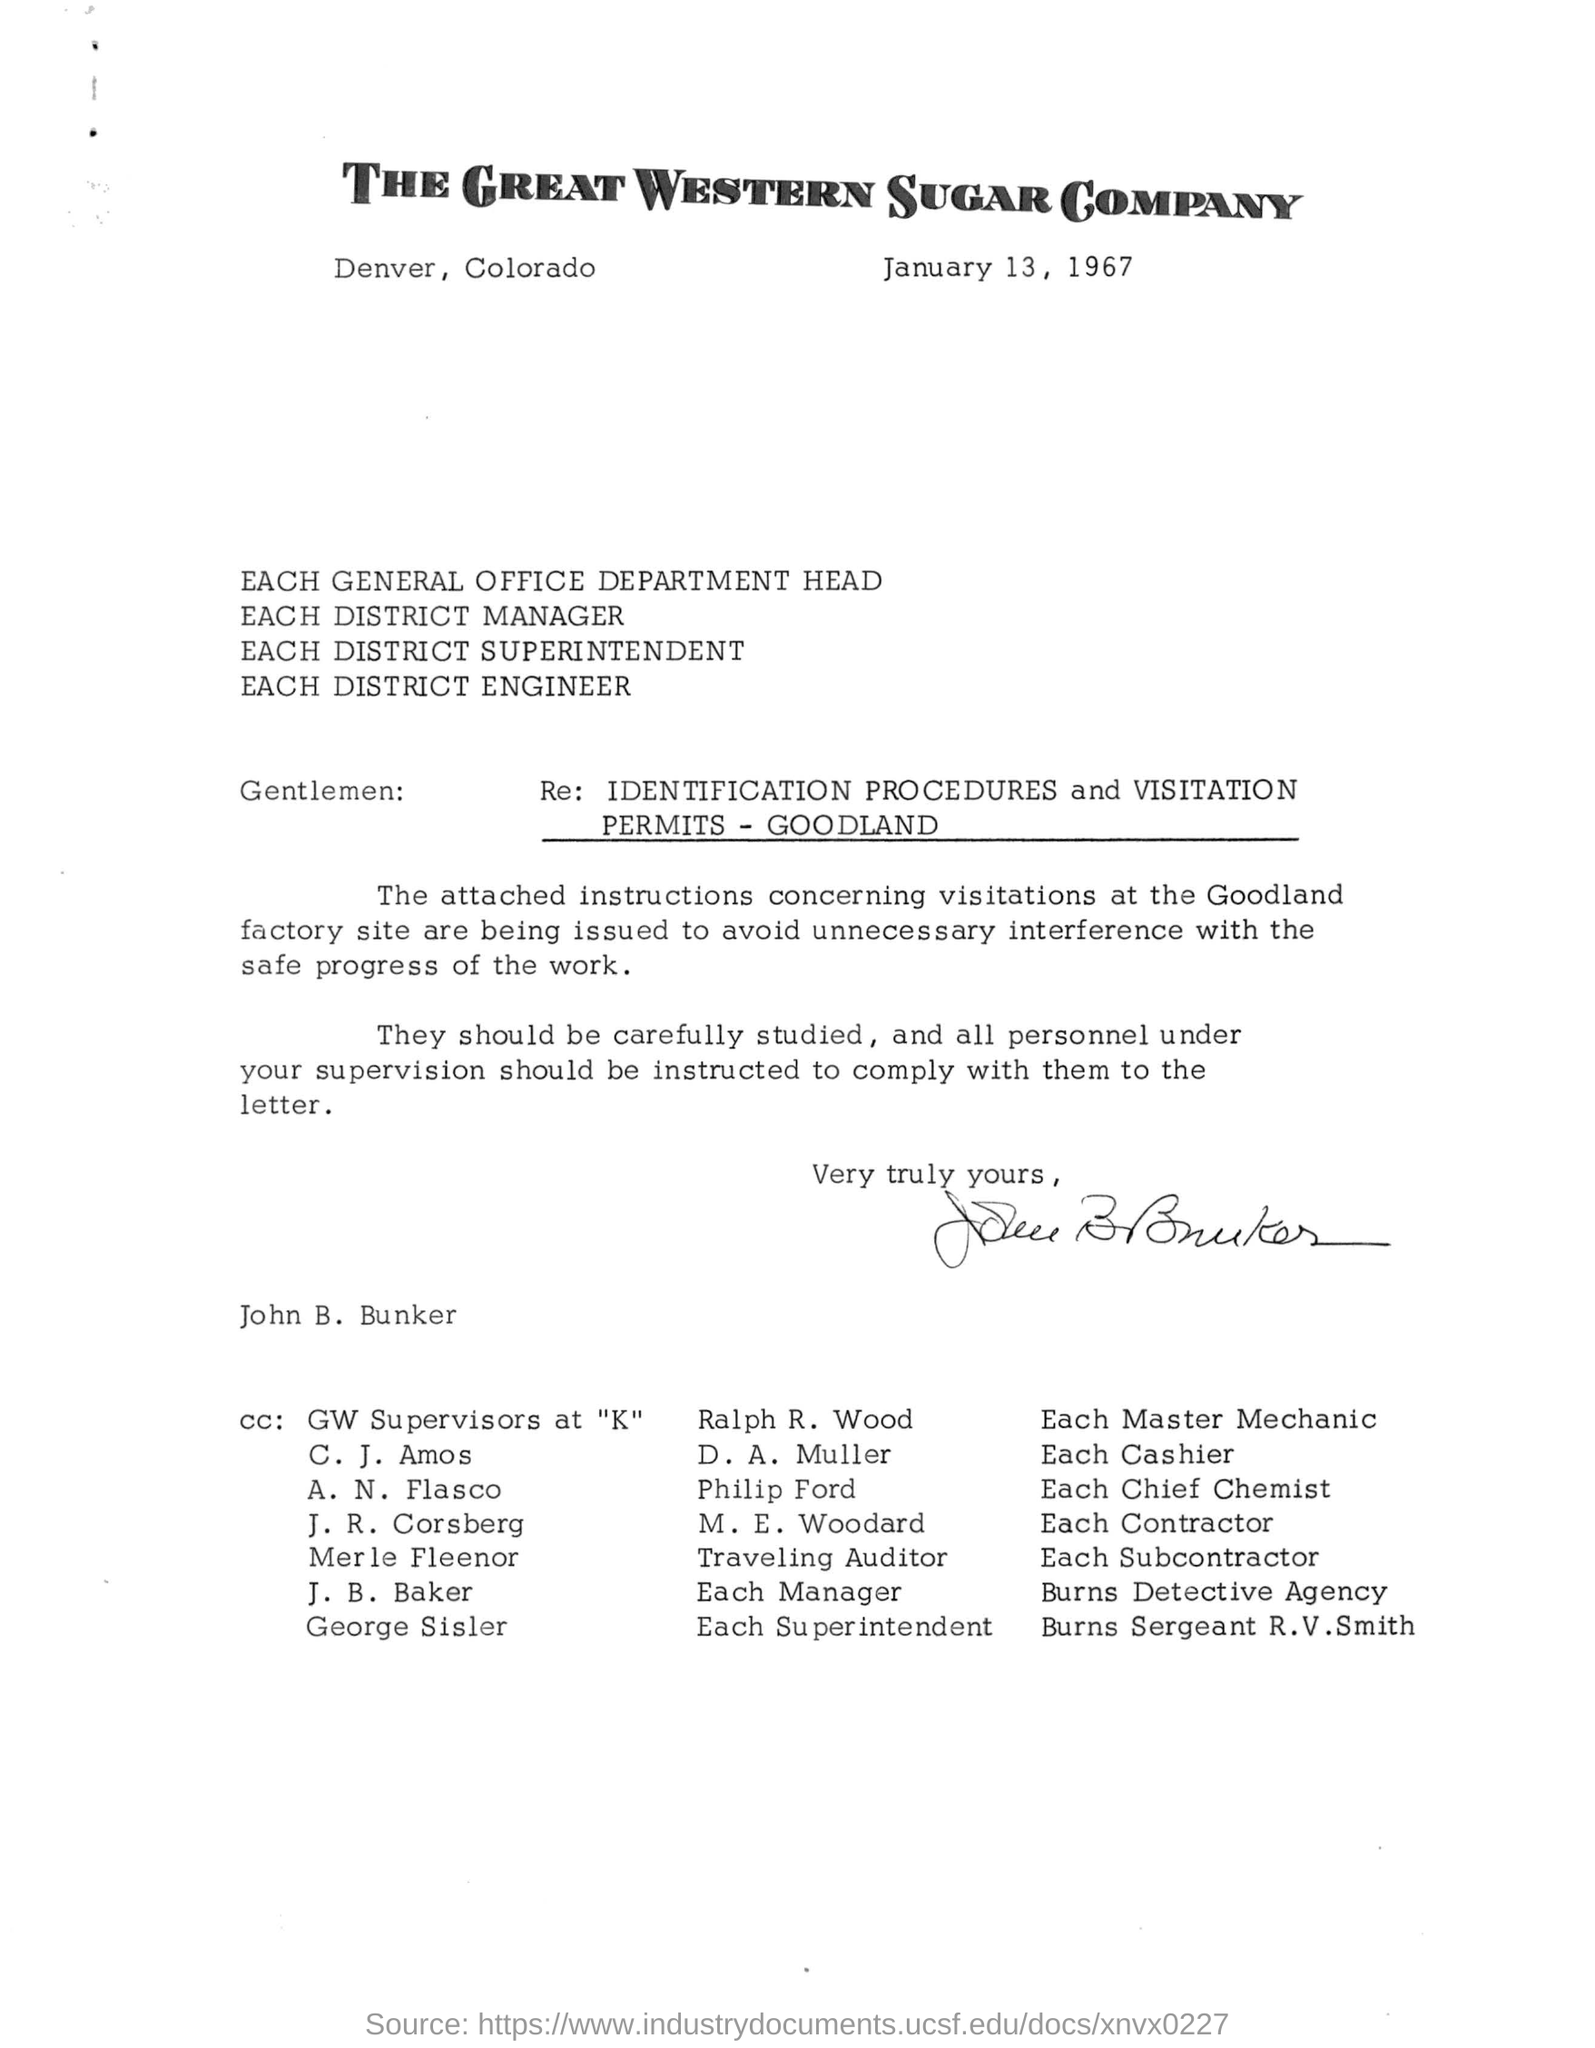What is the date mentioned in the letter?
Provide a succinct answer. January 13, 1967. 